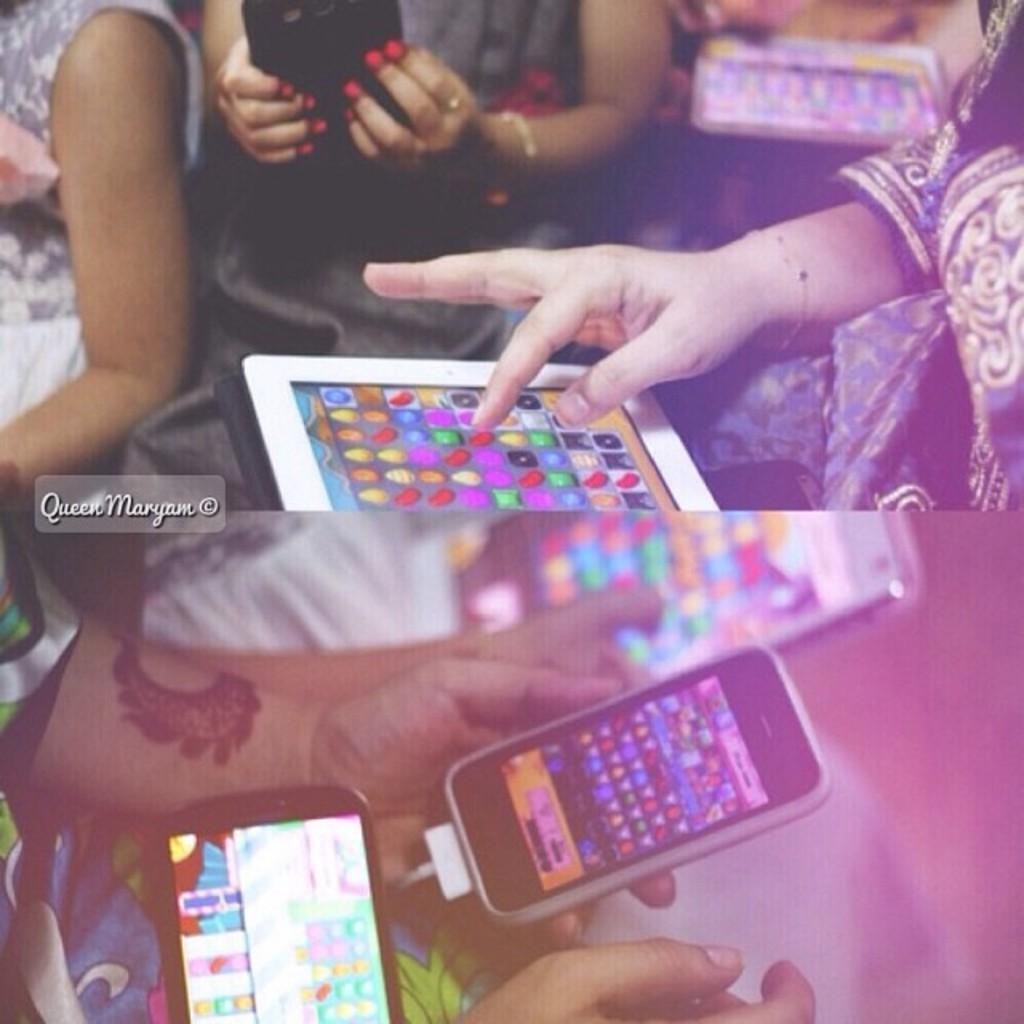Can you describe this image briefly? This is the collage of two pictures in which there are some person hand in which there are some phones and also we can see some things displayed on the screens. 